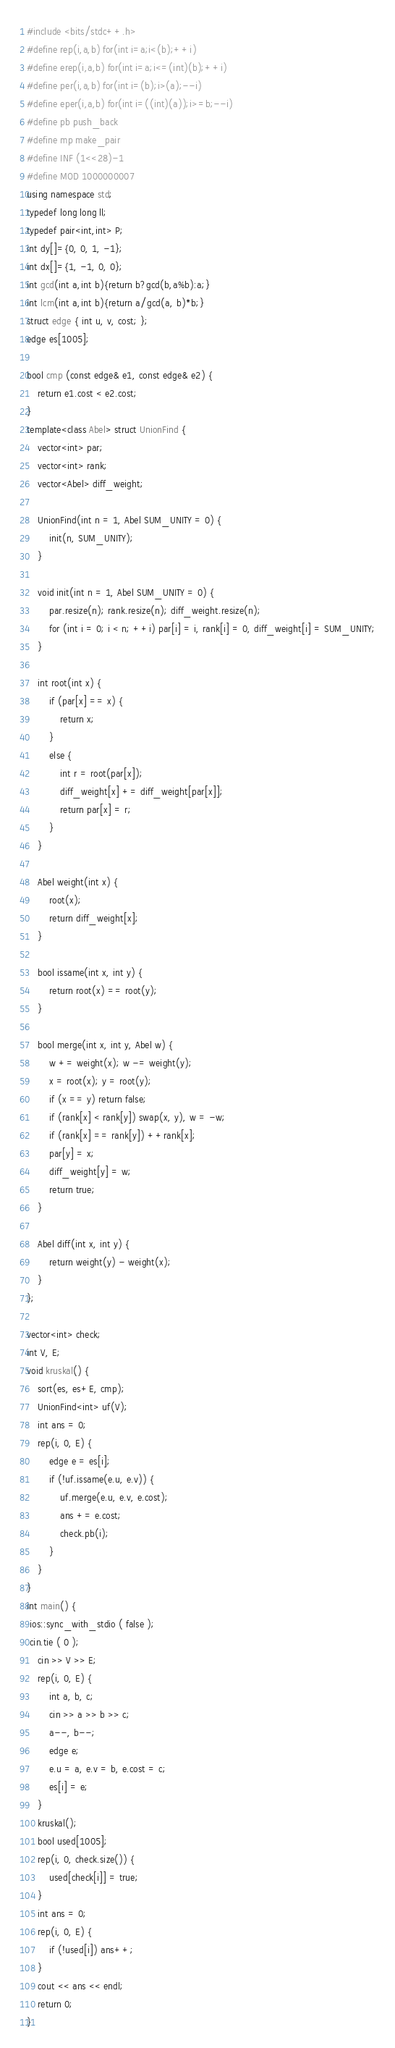<code> <loc_0><loc_0><loc_500><loc_500><_C++_>#include <bits/stdc++.h>
#define rep(i,a,b) for(int i=a;i<(b);++i)
#define erep(i,a,b) for(int i=a;i<=(int)(b);++i)
#define per(i,a,b) for(int i=(b);i>(a);--i)
#define eper(i,a,b) for(int i=((int)(a));i>=b;--i)
#define pb push_back
#define mp make_pair
#define INF (1<<28)-1
#define MOD 1000000007
using namespace std;
typedef long long ll;
typedef pair<int,int> P;
int dy[]={0, 0, 1, -1};
int dx[]={1, -1, 0, 0};
int gcd(int a,int b){return b?gcd(b,a%b):a;}
int lcm(int a,int b){return a/gcd(a, b)*b;}
struct edge { int u, v, cost; };
edge es[1005];

bool cmp (const edge& e1, const edge& e2) {
    return e1.cost < e2.cost;
}
template<class Abel> struct UnionFind {
    vector<int> par;
    vector<int> rank;
    vector<Abel> diff_weight;

    UnionFind(int n = 1, Abel SUM_UNITY = 0) {
        init(n, SUM_UNITY);
    }

    void init(int n = 1, Abel SUM_UNITY = 0) {
        par.resize(n); rank.resize(n); diff_weight.resize(n);
        for (int i = 0; i < n; ++i) par[i] = i, rank[i] = 0, diff_weight[i] = SUM_UNITY;
    }

    int root(int x) {
        if (par[x] == x) {
            return x;
        }
        else {
            int r = root(par[x]);
            diff_weight[x] += diff_weight[par[x]];
            return par[x] = r;
        }
    }

    Abel weight(int x) {
        root(x);
        return diff_weight[x];
    }

    bool issame(int x, int y) {
        return root(x) == root(y);
    }

    bool merge(int x, int y, Abel w) {
        w += weight(x); w -= weight(y);
        x = root(x); y = root(y);
        if (x == y) return false;
        if (rank[x] < rank[y]) swap(x, y), w = -w;
        if (rank[x] == rank[y]) ++rank[x];
        par[y] = x;
        diff_weight[y] = w;
        return true;
    }

    Abel diff(int x, int y) {
        return weight(y) - weight(x);
    }
};

vector<int> check;
int V, E; 
void kruskal() {
    sort(es, es+E, cmp);
    UnionFind<int> uf(V);
    int ans = 0;
    rep(i, 0, E) {
        edge e = es[i];
        if (!uf.issame(e.u, e.v)) {
            uf.merge(e.u, e.v, e.cost);
            ans += e.cost;
            check.pb(i);
        }
    }
}
int main() {
 ios::sync_with_stdio ( false );
 cin.tie ( 0 );
    cin >> V >> E;
    rep(i, 0, E) {
        int a, b, c;
        cin >> a >> b >> c;
        a--, b--;
        edge e;
        e.u = a, e.v = b, e.cost = c;
        es[i] = e;
    }
    kruskal();
    bool used[1005];
    rep(i, 0, check.size()) {
        used[check[i]] = true;
    }
    int ans = 0;
    rep(i, 0, E) {
        if (!used[i]) ans++;
    }
    cout << ans << endl;
    return 0;
}
</code> 